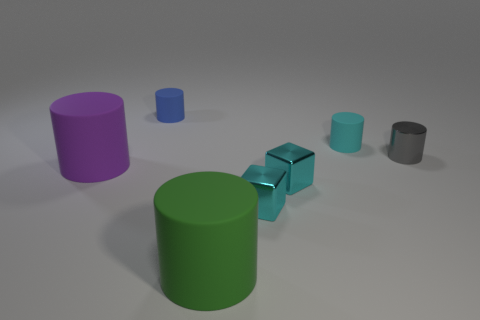Are there fewer green matte objects behind the small cyan cylinder than small cyan things in front of the small gray cylinder?
Ensure brevity in your answer.  Yes. The other big cylinder that is made of the same material as the green cylinder is what color?
Provide a succinct answer. Purple. There is a big rubber object that is on the left side of the small object that is to the left of the big green cylinder; what color is it?
Provide a succinct answer. Purple. The gray shiny object that is the same size as the cyan cylinder is what shape?
Provide a short and direct response. Cylinder. How many cylinders are to the left of the cyan object behind the large purple cylinder?
Keep it short and to the point. 3. What number of other objects are the same material as the green object?
Make the answer very short. 3. There is a cyan object behind the big cylinder that is on the left side of the green rubber thing; what is its shape?
Your answer should be compact. Cylinder. What size is the matte thing that is in front of the purple cylinder?
Keep it short and to the point. Large. Is the material of the tiny blue cylinder the same as the tiny gray cylinder?
Keep it short and to the point. No. What color is the small thing that is to the left of the green cylinder?
Keep it short and to the point. Blue. 